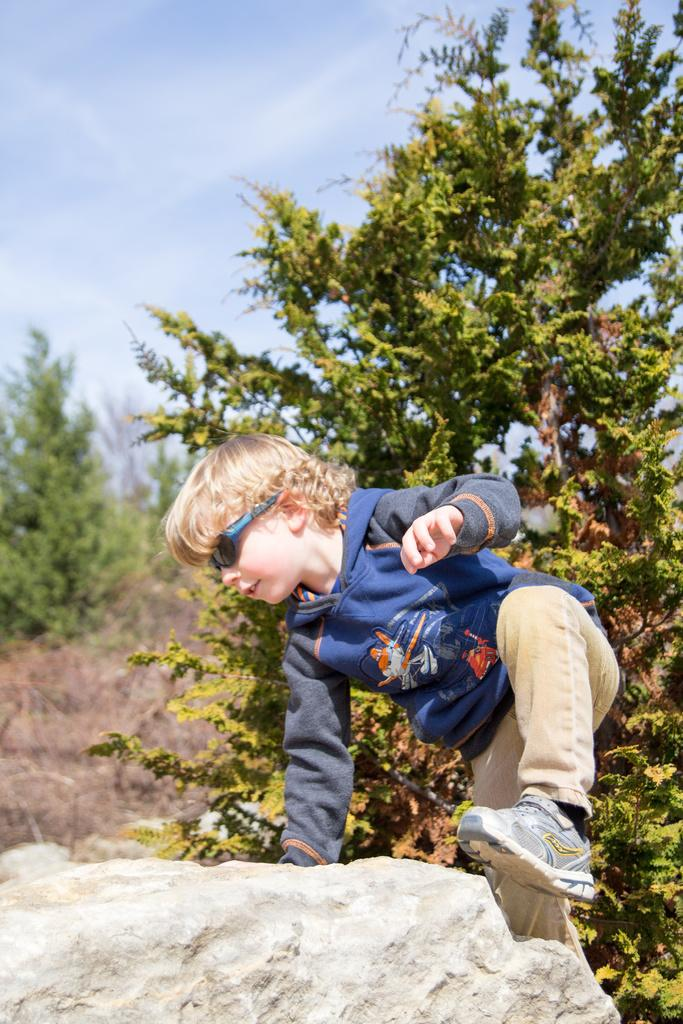What is the main subject of the image? The main subject of the image is a child. What is the child wearing? The child is wearing a blue T-shirt, glasses, and shoes. What activity is the child engaged in? The child is climbing a rock. What can be seen in the background of the image? There are trees and the sky visible in the background of the image. What is the condition of the sky in the image? Clouds are present in the sky. How does the child wash their feet in the image? There is no indication in the image that the child is washing their feet, as they are climbing a rock. What thought is the child having while climbing the rock in the image? There is no way to determine the child's thoughts from the image alone. 